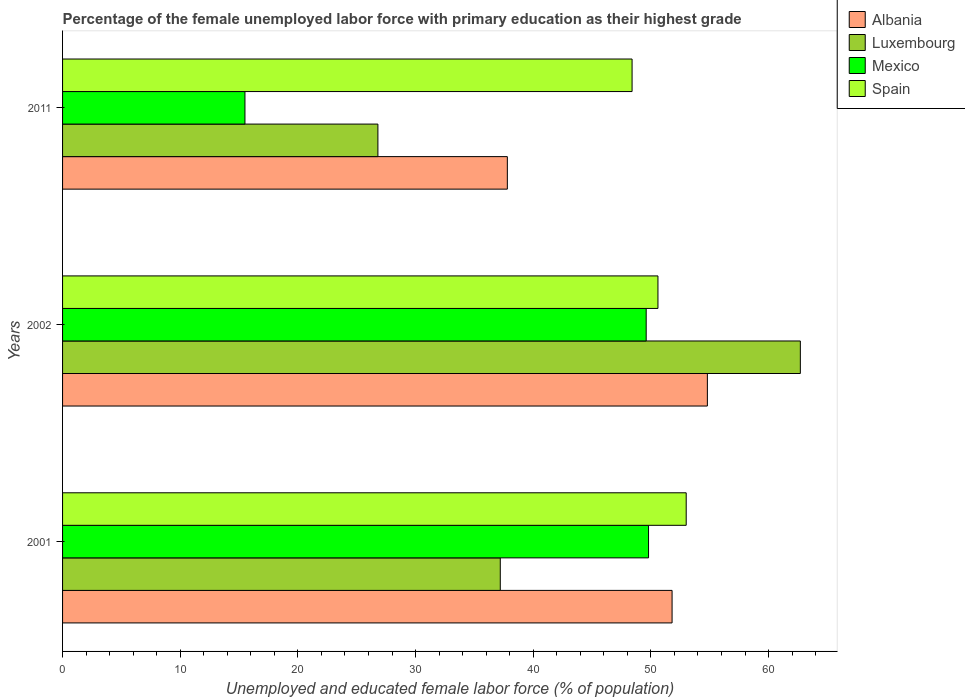How many groups of bars are there?
Provide a short and direct response. 3. Are the number of bars per tick equal to the number of legend labels?
Give a very brief answer. Yes. What is the label of the 1st group of bars from the top?
Your answer should be very brief. 2011. In how many cases, is the number of bars for a given year not equal to the number of legend labels?
Make the answer very short. 0. What is the percentage of the unemployed female labor force with primary education in Luxembourg in 2011?
Offer a terse response. 26.8. Across all years, what is the maximum percentage of the unemployed female labor force with primary education in Albania?
Make the answer very short. 54.8. Across all years, what is the minimum percentage of the unemployed female labor force with primary education in Albania?
Offer a terse response. 37.8. In which year was the percentage of the unemployed female labor force with primary education in Luxembourg minimum?
Make the answer very short. 2011. What is the total percentage of the unemployed female labor force with primary education in Luxembourg in the graph?
Provide a short and direct response. 126.7. What is the difference between the percentage of the unemployed female labor force with primary education in Mexico in 2001 and that in 2002?
Give a very brief answer. 0.2. What is the difference between the percentage of the unemployed female labor force with primary education in Luxembourg in 2011 and the percentage of the unemployed female labor force with primary education in Mexico in 2002?
Your answer should be very brief. -22.8. What is the average percentage of the unemployed female labor force with primary education in Mexico per year?
Ensure brevity in your answer.  38.3. In the year 2011, what is the difference between the percentage of the unemployed female labor force with primary education in Mexico and percentage of the unemployed female labor force with primary education in Luxembourg?
Your answer should be very brief. -11.3. In how many years, is the percentage of the unemployed female labor force with primary education in Luxembourg greater than 24 %?
Offer a terse response. 3. What is the ratio of the percentage of the unemployed female labor force with primary education in Albania in 2002 to that in 2011?
Give a very brief answer. 1.45. Is the percentage of the unemployed female labor force with primary education in Mexico in 2001 less than that in 2011?
Your answer should be very brief. No. What is the difference between the highest and the second highest percentage of the unemployed female labor force with primary education in Luxembourg?
Keep it short and to the point. 25.5. What is the difference between the highest and the lowest percentage of the unemployed female labor force with primary education in Spain?
Provide a short and direct response. 4.6. In how many years, is the percentage of the unemployed female labor force with primary education in Luxembourg greater than the average percentage of the unemployed female labor force with primary education in Luxembourg taken over all years?
Provide a short and direct response. 1. Is the sum of the percentage of the unemployed female labor force with primary education in Mexico in 2001 and 2011 greater than the maximum percentage of the unemployed female labor force with primary education in Luxembourg across all years?
Offer a terse response. Yes. What does the 3rd bar from the top in 2011 represents?
Offer a terse response. Luxembourg. What does the 1st bar from the bottom in 2011 represents?
Your response must be concise. Albania. Is it the case that in every year, the sum of the percentage of the unemployed female labor force with primary education in Albania and percentage of the unemployed female labor force with primary education in Luxembourg is greater than the percentage of the unemployed female labor force with primary education in Mexico?
Your response must be concise. Yes. Does the graph contain grids?
Provide a short and direct response. No. Where does the legend appear in the graph?
Offer a terse response. Top right. How many legend labels are there?
Offer a very short reply. 4. What is the title of the graph?
Offer a very short reply. Percentage of the female unemployed labor force with primary education as their highest grade. What is the label or title of the X-axis?
Ensure brevity in your answer.  Unemployed and educated female labor force (% of population). What is the Unemployed and educated female labor force (% of population) in Albania in 2001?
Keep it short and to the point. 51.8. What is the Unemployed and educated female labor force (% of population) of Luxembourg in 2001?
Make the answer very short. 37.2. What is the Unemployed and educated female labor force (% of population) of Mexico in 2001?
Provide a succinct answer. 49.8. What is the Unemployed and educated female labor force (% of population) of Spain in 2001?
Provide a succinct answer. 53. What is the Unemployed and educated female labor force (% of population) of Albania in 2002?
Make the answer very short. 54.8. What is the Unemployed and educated female labor force (% of population) in Luxembourg in 2002?
Ensure brevity in your answer.  62.7. What is the Unemployed and educated female labor force (% of population) of Mexico in 2002?
Provide a succinct answer. 49.6. What is the Unemployed and educated female labor force (% of population) of Spain in 2002?
Provide a succinct answer. 50.6. What is the Unemployed and educated female labor force (% of population) in Albania in 2011?
Give a very brief answer. 37.8. What is the Unemployed and educated female labor force (% of population) in Luxembourg in 2011?
Ensure brevity in your answer.  26.8. What is the Unemployed and educated female labor force (% of population) in Spain in 2011?
Ensure brevity in your answer.  48.4. Across all years, what is the maximum Unemployed and educated female labor force (% of population) in Albania?
Keep it short and to the point. 54.8. Across all years, what is the maximum Unemployed and educated female labor force (% of population) of Luxembourg?
Offer a very short reply. 62.7. Across all years, what is the maximum Unemployed and educated female labor force (% of population) of Mexico?
Ensure brevity in your answer.  49.8. Across all years, what is the maximum Unemployed and educated female labor force (% of population) of Spain?
Provide a short and direct response. 53. Across all years, what is the minimum Unemployed and educated female labor force (% of population) in Albania?
Ensure brevity in your answer.  37.8. Across all years, what is the minimum Unemployed and educated female labor force (% of population) of Luxembourg?
Give a very brief answer. 26.8. Across all years, what is the minimum Unemployed and educated female labor force (% of population) of Spain?
Keep it short and to the point. 48.4. What is the total Unemployed and educated female labor force (% of population) of Albania in the graph?
Provide a short and direct response. 144.4. What is the total Unemployed and educated female labor force (% of population) of Luxembourg in the graph?
Your response must be concise. 126.7. What is the total Unemployed and educated female labor force (% of population) of Mexico in the graph?
Offer a very short reply. 114.9. What is the total Unemployed and educated female labor force (% of population) in Spain in the graph?
Offer a very short reply. 152. What is the difference between the Unemployed and educated female labor force (% of population) of Albania in 2001 and that in 2002?
Give a very brief answer. -3. What is the difference between the Unemployed and educated female labor force (% of population) of Luxembourg in 2001 and that in 2002?
Provide a short and direct response. -25.5. What is the difference between the Unemployed and educated female labor force (% of population) of Albania in 2001 and that in 2011?
Offer a very short reply. 14. What is the difference between the Unemployed and educated female labor force (% of population) in Mexico in 2001 and that in 2011?
Provide a succinct answer. 34.3. What is the difference between the Unemployed and educated female labor force (% of population) of Albania in 2002 and that in 2011?
Keep it short and to the point. 17. What is the difference between the Unemployed and educated female labor force (% of population) in Luxembourg in 2002 and that in 2011?
Ensure brevity in your answer.  35.9. What is the difference between the Unemployed and educated female labor force (% of population) of Mexico in 2002 and that in 2011?
Your response must be concise. 34.1. What is the difference between the Unemployed and educated female labor force (% of population) in Albania in 2001 and the Unemployed and educated female labor force (% of population) in Spain in 2002?
Keep it short and to the point. 1.2. What is the difference between the Unemployed and educated female labor force (% of population) of Mexico in 2001 and the Unemployed and educated female labor force (% of population) of Spain in 2002?
Offer a very short reply. -0.8. What is the difference between the Unemployed and educated female labor force (% of population) in Albania in 2001 and the Unemployed and educated female labor force (% of population) in Luxembourg in 2011?
Offer a very short reply. 25. What is the difference between the Unemployed and educated female labor force (% of population) of Albania in 2001 and the Unemployed and educated female labor force (% of population) of Mexico in 2011?
Make the answer very short. 36.3. What is the difference between the Unemployed and educated female labor force (% of population) in Albania in 2001 and the Unemployed and educated female labor force (% of population) in Spain in 2011?
Your answer should be very brief. 3.4. What is the difference between the Unemployed and educated female labor force (% of population) of Luxembourg in 2001 and the Unemployed and educated female labor force (% of population) of Mexico in 2011?
Your answer should be very brief. 21.7. What is the difference between the Unemployed and educated female labor force (% of population) in Luxembourg in 2001 and the Unemployed and educated female labor force (% of population) in Spain in 2011?
Make the answer very short. -11.2. What is the difference between the Unemployed and educated female labor force (% of population) in Albania in 2002 and the Unemployed and educated female labor force (% of population) in Luxembourg in 2011?
Ensure brevity in your answer.  28. What is the difference between the Unemployed and educated female labor force (% of population) in Albania in 2002 and the Unemployed and educated female labor force (% of population) in Mexico in 2011?
Your response must be concise. 39.3. What is the difference between the Unemployed and educated female labor force (% of population) of Albania in 2002 and the Unemployed and educated female labor force (% of population) of Spain in 2011?
Offer a very short reply. 6.4. What is the difference between the Unemployed and educated female labor force (% of population) of Luxembourg in 2002 and the Unemployed and educated female labor force (% of population) of Mexico in 2011?
Offer a very short reply. 47.2. What is the difference between the Unemployed and educated female labor force (% of population) in Mexico in 2002 and the Unemployed and educated female labor force (% of population) in Spain in 2011?
Give a very brief answer. 1.2. What is the average Unemployed and educated female labor force (% of population) of Albania per year?
Keep it short and to the point. 48.13. What is the average Unemployed and educated female labor force (% of population) in Luxembourg per year?
Offer a terse response. 42.23. What is the average Unemployed and educated female labor force (% of population) in Mexico per year?
Your response must be concise. 38.3. What is the average Unemployed and educated female labor force (% of population) in Spain per year?
Your answer should be compact. 50.67. In the year 2001, what is the difference between the Unemployed and educated female labor force (% of population) of Albania and Unemployed and educated female labor force (% of population) of Mexico?
Provide a short and direct response. 2. In the year 2001, what is the difference between the Unemployed and educated female labor force (% of population) in Albania and Unemployed and educated female labor force (% of population) in Spain?
Your answer should be compact. -1.2. In the year 2001, what is the difference between the Unemployed and educated female labor force (% of population) in Luxembourg and Unemployed and educated female labor force (% of population) in Spain?
Your answer should be compact. -15.8. In the year 2002, what is the difference between the Unemployed and educated female labor force (% of population) in Albania and Unemployed and educated female labor force (% of population) in Mexico?
Your answer should be compact. 5.2. In the year 2002, what is the difference between the Unemployed and educated female labor force (% of population) of Albania and Unemployed and educated female labor force (% of population) of Spain?
Keep it short and to the point. 4.2. In the year 2002, what is the difference between the Unemployed and educated female labor force (% of population) in Luxembourg and Unemployed and educated female labor force (% of population) in Spain?
Ensure brevity in your answer.  12.1. In the year 2002, what is the difference between the Unemployed and educated female labor force (% of population) in Mexico and Unemployed and educated female labor force (% of population) in Spain?
Provide a succinct answer. -1. In the year 2011, what is the difference between the Unemployed and educated female labor force (% of population) of Albania and Unemployed and educated female labor force (% of population) of Mexico?
Provide a short and direct response. 22.3. In the year 2011, what is the difference between the Unemployed and educated female labor force (% of population) in Albania and Unemployed and educated female labor force (% of population) in Spain?
Your answer should be compact. -10.6. In the year 2011, what is the difference between the Unemployed and educated female labor force (% of population) in Luxembourg and Unemployed and educated female labor force (% of population) in Mexico?
Keep it short and to the point. 11.3. In the year 2011, what is the difference between the Unemployed and educated female labor force (% of population) in Luxembourg and Unemployed and educated female labor force (% of population) in Spain?
Make the answer very short. -21.6. In the year 2011, what is the difference between the Unemployed and educated female labor force (% of population) of Mexico and Unemployed and educated female labor force (% of population) of Spain?
Your answer should be very brief. -32.9. What is the ratio of the Unemployed and educated female labor force (% of population) of Albania in 2001 to that in 2002?
Ensure brevity in your answer.  0.95. What is the ratio of the Unemployed and educated female labor force (% of population) of Luxembourg in 2001 to that in 2002?
Your response must be concise. 0.59. What is the ratio of the Unemployed and educated female labor force (% of population) in Spain in 2001 to that in 2002?
Make the answer very short. 1.05. What is the ratio of the Unemployed and educated female labor force (% of population) of Albania in 2001 to that in 2011?
Make the answer very short. 1.37. What is the ratio of the Unemployed and educated female labor force (% of population) of Luxembourg in 2001 to that in 2011?
Provide a succinct answer. 1.39. What is the ratio of the Unemployed and educated female labor force (% of population) in Mexico in 2001 to that in 2011?
Keep it short and to the point. 3.21. What is the ratio of the Unemployed and educated female labor force (% of population) of Spain in 2001 to that in 2011?
Give a very brief answer. 1.09. What is the ratio of the Unemployed and educated female labor force (% of population) of Albania in 2002 to that in 2011?
Provide a short and direct response. 1.45. What is the ratio of the Unemployed and educated female labor force (% of population) of Luxembourg in 2002 to that in 2011?
Offer a terse response. 2.34. What is the ratio of the Unemployed and educated female labor force (% of population) in Spain in 2002 to that in 2011?
Make the answer very short. 1.05. What is the difference between the highest and the second highest Unemployed and educated female labor force (% of population) of Albania?
Offer a very short reply. 3. What is the difference between the highest and the second highest Unemployed and educated female labor force (% of population) of Spain?
Your answer should be very brief. 2.4. What is the difference between the highest and the lowest Unemployed and educated female labor force (% of population) of Albania?
Your answer should be compact. 17. What is the difference between the highest and the lowest Unemployed and educated female labor force (% of population) in Luxembourg?
Offer a terse response. 35.9. What is the difference between the highest and the lowest Unemployed and educated female labor force (% of population) of Mexico?
Your answer should be very brief. 34.3. What is the difference between the highest and the lowest Unemployed and educated female labor force (% of population) of Spain?
Offer a very short reply. 4.6. 